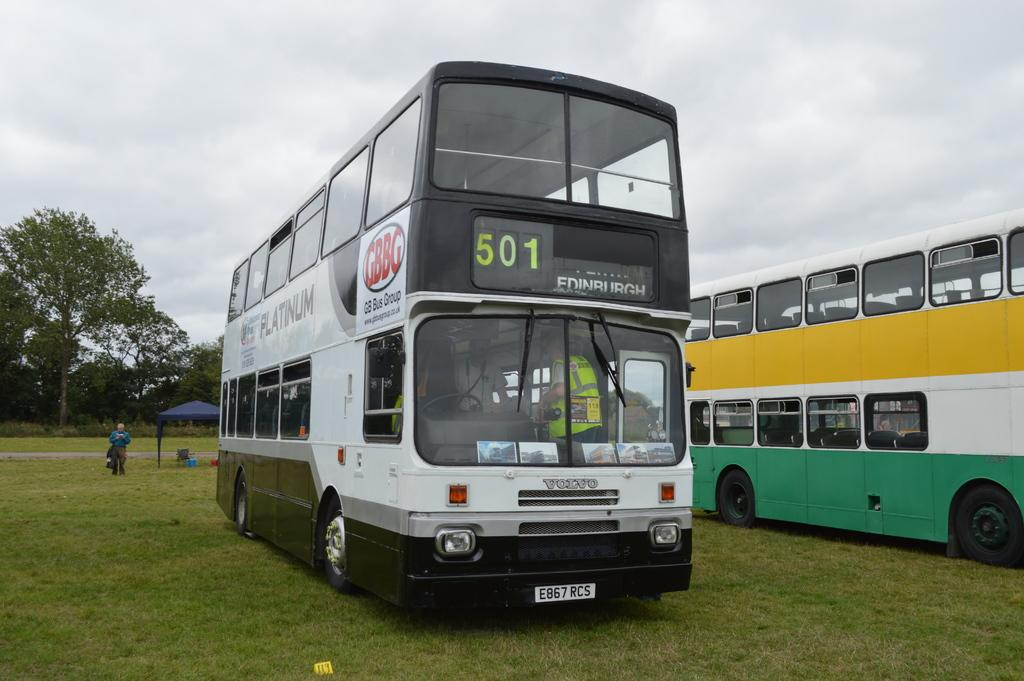What can be seen on the ground in the image? There are two vehicles on the ground in the image. What is the person near the vehicles doing? A person is standing near the vehicles in the image. What is visible in the background of the image? There is a tent and many trees in the background, as well as the sky. What type of fear can be seen on the potato in the image? There is no potato present in the image, and therefore no fear can be observed. 